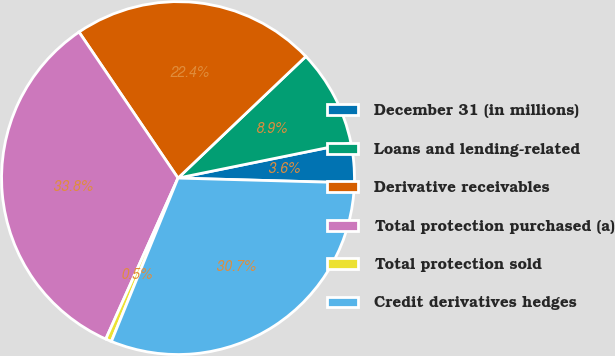Convert chart. <chart><loc_0><loc_0><loc_500><loc_500><pie_chart><fcel>December 31 (in millions)<fcel>Loans and lending-related<fcel>Derivative receivables<fcel>Total protection purchased (a)<fcel>Total protection sold<fcel>Credit derivatives hedges<nl><fcel>3.63%<fcel>8.91%<fcel>22.38%<fcel>33.81%<fcel>0.55%<fcel>30.73%<nl></chart> 